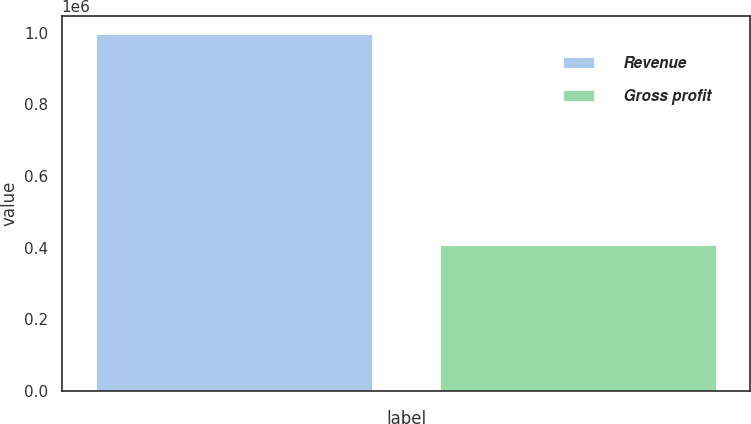<chart> <loc_0><loc_0><loc_500><loc_500><bar_chart><fcel>Revenue<fcel>Gross profit<nl><fcel>996668<fcel>407600<nl></chart> 